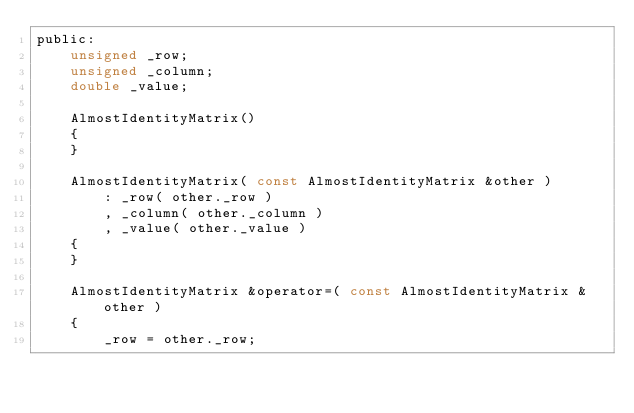Convert code to text. <code><loc_0><loc_0><loc_500><loc_500><_C_>public:
    unsigned _row;
    unsigned _column;
    double _value;

    AlmostIdentityMatrix()
    {
    }

    AlmostIdentityMatrix( const AlmostIdentityMatrix &other )
        : _row( other._row )
        , _column( other._column )
        , _value( other._value )
    {
    }

    AlmostIdentityMatrix &operator=( const AlmostIdentityMatrix &other )
    {
        _row = other._row;</code> 